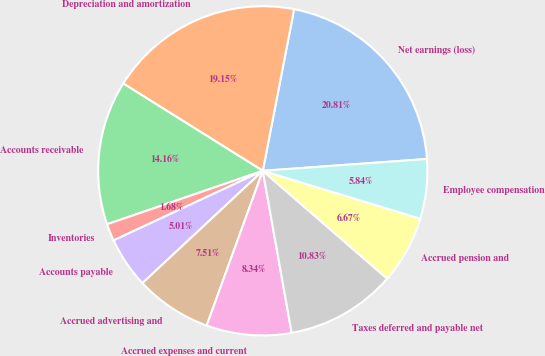Convert chart. <chart><loc_0><loc_0><loc_500><loc_500><pie_chart><fcel>Net earnings (loss)<fcel>Depreciation and amortization<fcel>Accounts receivable<fcel>Inventories<fcel>Accounts payable<fcel>Accrued advertising and<fcel>Accrued expenses and current<fcel>Taxes deferred and payable net<fcel>Accrued pension and<fcel>Employee compensation<nl><fcel>20.81%<fcel>19.15%<fcel>14.16%<fcel>1.68%<fcel>5.01%<fcel>7.51%<fcel>8.34%<fcel>10.83%<fcel>6.67%<fcel>5.84%<nl></chart> 